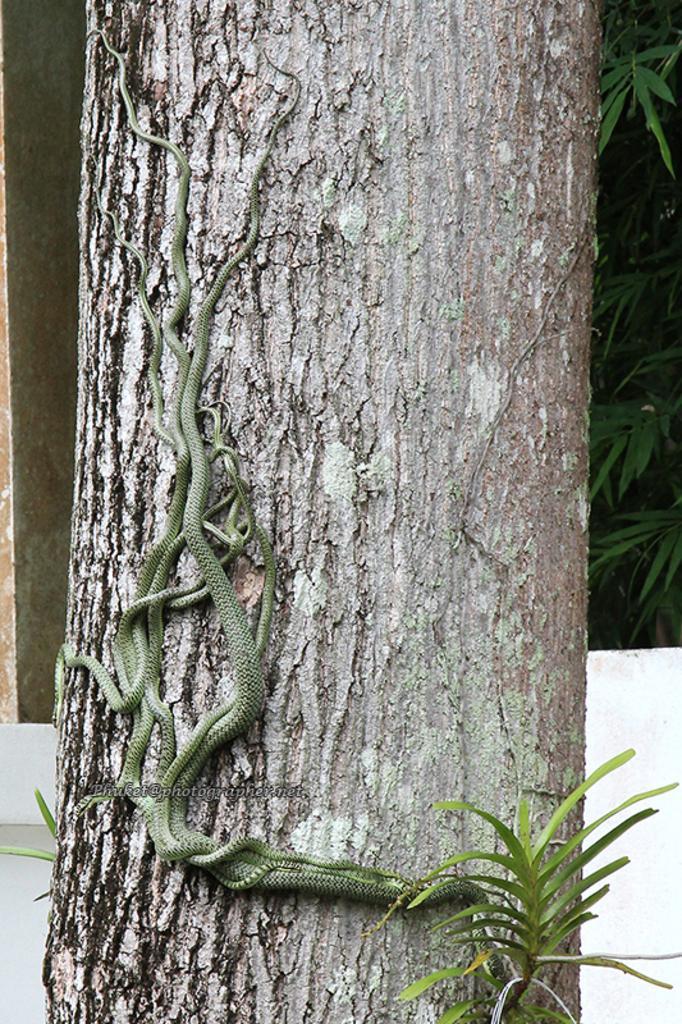In one or two sentences, can you explain what this image depicts? In this image I can see something on the tree. 